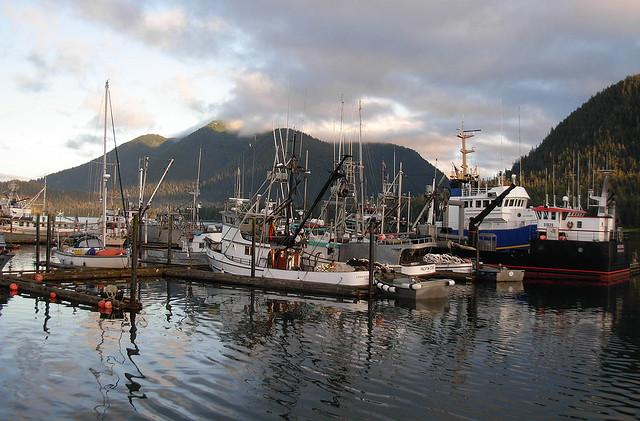What color are the lateral stripes wrapped around the black bodied boat?

Choices:
A) orange
B) red
C) white
D) yellow red 